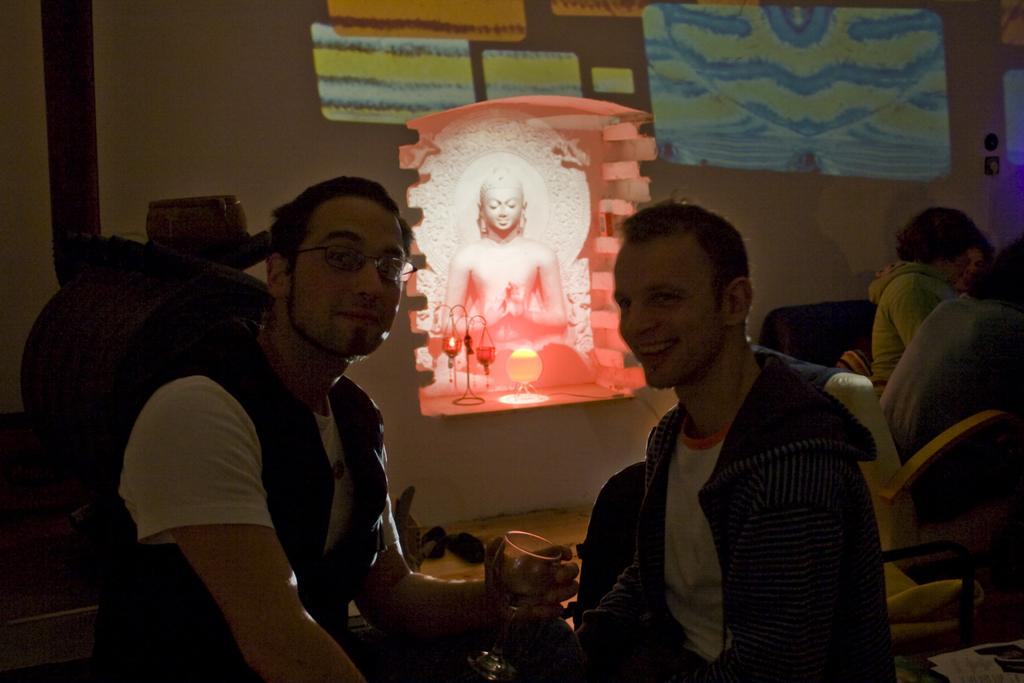What is happening in the image? There is a group of people in the image, and they are sitting on chairs. Can you describe the man in the image? The man is holding a glass in his hand and smiling. What can be seen in the background of the image? There is a wall and a statue in the background of the image. Where is the boy standing next to the oven in the image? There is no boy or oven present in the image. 